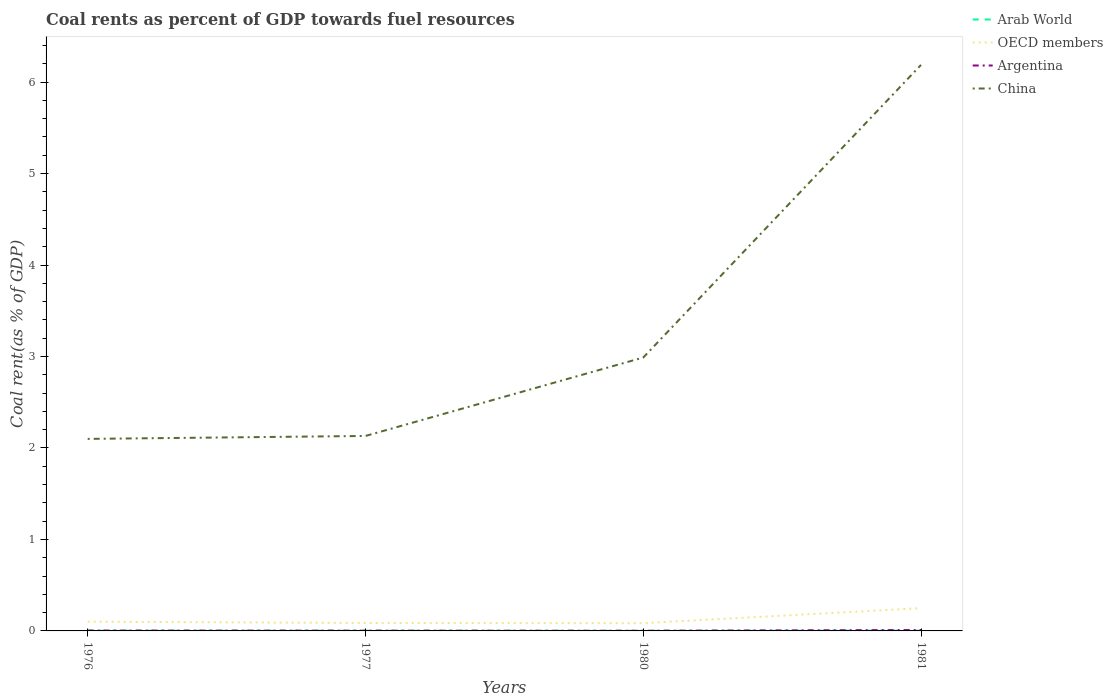Does the line corresponding to OECD members intersect with the line corresponding to China?
Ensure brevity in your answer.  No. Is the number of lines equal to the number of legend labels?
Provide a succinct answer. Yes. Across all years, what is the maximum coal rent in OECD members?
Your answer should be compact. 0.08. What is the total coal rent in OECD members in the graph?
Your answer should be very brief. -0.15. What is the difference between the highest and the second highest coal rent in Arab World?
Provide a succinct answer. 0. What is the difference between the highest and the lowest coal rent in China?
Ensure brevity in your answer.  1. Is the coal rent in Argentina strictly greater than the coal rent in Arab World over the years?
Make the answer very short. No. How many years are there in the graph?
Your answer should be very brief. 4. Does the graph contain any zero values?
Ensure brevity in your answer.  No. Does the graph contain grids?
Ensure brevity in your answer.  No. Where does the legend appear in the graph?
Ensure brevity in your answer.  Top right. How many legend labels are there?
Offer a very short reply. 4. What is the title of the graph?
Provide a short and direct response. Coal rents as percent of GDP towards fuel resources. What is the label or title of the X-axis?
Your answer should be very brief. Years. What is the label or title of the Y-axis?
Provide a succinct answer. Coal rent(as % of GDP). What is the Coal rent(as % of GDP) of Arab World in 1976?
Provide a short and direct response. 0. What is the Coal rent(as % of GDP) in OECD members in 1976?
Ensure brevity in your answer.  0.1. What is the Coal rent(as % of GDP) in Argentina in 1976?
Provide a short and direct response. 0. What is the Coal rent(as % of GDP) of China in 1976?
Ensure brevity in your answer.  2.1. What is the Coal rent(as % of GDP) of Arab World in 1977?
Ensure brevity in your answer.  0. What is the Coal rent(as % of GDP) in OECD members in 1977?
Offer a very short reply. 0.09. What is the Coal rent(as % of GDP) in Argentina in 1977?
Your answer should be very brief. 0. What is the Coal rent(as % of GDP) in China in 1977?
Ensure brevity in your answer.  2.13. What is the Coal rent(as % of GDP) of Arab World in 1980?
Provide a succinct answer. 0. What is the Coal rent(as % of GDP) of OECD members in 1980?
Provide a succinct answer. 0.08. What is the Coal rent(as % of GDP) of Argentina in 1980?
Offer a terse response. 0. What is the Coal rent(as % of GDP) in China in 1980?
Make the answer very short. 2.99. What is the Coal rent(as % of GDP) of Arab World in 1981?
Offer a terse response. 0. What is the Coal rent(as % of GDP) in OECD members in 1981?
Ensure brevity in your answer.  0.25. What is the Coal rent(as % of GDP) of Argentina in 1981?
Provide a short and direct response. 0.01. What is the Coal rent(as % of GDP) of China in 1981?
Offer a terse response. 6.19. Across all years, what is the maximum Coal rent(as % of GDP) in Arab World?
Offer a terse response. 0. Across all years, what is the maximum Coal rent(as % of GDP) in OECD members?
Your answer should be compact. 0.25. Across all years, what is the maximum Coal rent(as % of GDP) in Argentina?
Provide a short and direct response. 0.01. Across all years, what is the maximum Coal rent(as % of GDP) in China?
Give a very brief answer. 6.19. Across all years, what is the minimum Coal rent(as % of GDP) in Arab World?
Your answer should be compact. 0. Across all years, what is the minimum Coal rent(as % of GDP) in OECD members?
Ensure brevity in your answer.  0.08. Across all years, what is the minimum Coal rent(as % of GDP) in Argentina?
Ensure brevity in your answer.  0. Across all years, what is the minimum Coal rent(as % of GDP) of China?
Offer a very short reply. 2.1. What is the total Coal rent(as % of GDP) of Arab World in the graph?
Provide a short and direct response. 0.01. What is the total Coal rent(as % of GDP) of OECD members in the graph?
Give a very brief answer. 0.52. What is the total Coal rent(as % of GDP) in Argentina in the graph?
Offer a terse response. 0.02. What is the total Coal rent(as % of GDP) in China in the graph?
Make the answer very short. 13.41. What is the difference between the Coal rent(as % of GDP) in OECD members in 1976 and that in 1977?
Make the answer very short. 0.01. What is the difference between the Coal rent(as % of GDP) in Argentina in 1976 and that in 1977?
Provide a succinct answer. 0. What is the difference between the Coal rent(as % of GDP) of China in 1976 and that in 1977?
Offer a very short reply. -0.03. What is the difference between the Coal rent(as % of GDP) in Arab World in 1976 and that in 1980?
Offer a very short reply. 0. What is the difference between the Coal rent(as % of GDP) in OECD members in 1976 and that in 1980?
Give a very brief answer. 0.02. What is the difference between the Coal rent(as % of GDP) in Argentina in 1976 and that in 1980?
Provide a short and direct response. 0. What is the difference between the Coal rent(as % of GDP) in China in 1976 and that in 1980?
Ensure brevity in your answer.  -0.89. What is the difference between the Coal rent(as % of GDP) in Arab World in 1976 and that in 1981?
Provide a succinct answer. -0. What is the difference between the Coal rent(as % of GDP) in OECD members in 1976 and that in 1981?
Provide a short and direct response. -0.15. What is the difference between the Coal rent(as % of GDP) of Argentina in 1976 and that in 1981?
Your answer should be very brief. -0.01. What is the difference between the Coal rent(as % of GDP) in China in 1976 and that in 1981?
Your answer should be very brief. -4.09. What is the difference between the Coal rent(as % of GDP) in Arab World in 1977 and that in 1980?
Offer a terse response. 0. What is the difference between the Coal rent(as % of GDP) of OECD members in 1977 and that in 1980?
Offer a very short reply. 0. What is the difference between the Coal rent(as % of GDP) in China in 1977 and that in 1980?
Offer a very short reply. -0.86. What is the difference between the Coal rent(as % of GDP) of Arab World in 1977 and that in 1981?
Provide a short and direct response. -0. What is the difference between the Coal rent(as % of GDP) in OECD members in 1977 and that in 1981?
Offer a terse response. -0.16. What is the difference between the Coal rent(as % of GDP) in Argentina in 1977 and that in 1981?
Give a very brief answer. -0.01. What is the difference between the Coal rent(as % of GDP) of China in 1977 and that in 1981?
Keep it short and to the point. -4.06. What is the difference between the Coal rent(as % of GDP) of Arab World in 1980 and that in 1981?
Provide a short and direct response. -0. What is the difference between the Coal rent(as % of GDP) in OECD members in 1980 and that in 1981?
Give a very brief answer. -0.16. What is the difference between the Coal rent(as % of GDP) of Argentina in 1980 and that in 1981?
Provide a short and direct response. -0.01. What is the difference between the Coal rent(as % of GDP) in China in 1980 and that in 1981?
Give a very brief answer. -3.2. What is the difference between the Coal rent(as % of GDP) in Arab World in 1976 and the Coal rent(as % of GDP) in OECD members in 1977?
Make the answer very short. -0.08. What is the difference between the Coal rent(as % of GDP) in Arab World in 1976 and the Coal rent(as % of GDP) in Argentina in 1977?
Offer a terse response. 0. What is the difference between the Coal rent(as % of GDP) of Arab World in 1976 and the Coal rent(as % of GDP) of China in 1977?
Make the answer very short. -2.13. What is the difference between the Coal rent(as % of GDP) in OECD members in 1976 and the Coal rent(as % of GDP) in Argentina in 1977?
Provide a short and direct response. 0.1. What is the difference between the Coal rent(as % of GDP) in OECD members in 1976 and the Coal rent(as % of GDP) in China in 1977?
Your response must be concise. -2.03. What is the difference between the Coal rent(as % of GDP) in Argentina in 1976 and the Coal rent(as % of GDP) in China in 1977?
Your answer should be very brief. -2.13. What is the difference between the Coal rent(as % of GDP) of Arab World in 1976 and the Coal rent(as % of GDP) of OECD members in 1980?
Give a very brief answer. -0.08. What is the difference between the Coal rent(as % of GDP) in Arab World in 1976 and the Coal rent(as % of GDP) in Argentina in 1980?
Keep it short and to the point. 0. What is the difference between the Coal rent(as % of GDP) of Arab World in 1976 and the Coal rent(as % of GDP) of China in 1980?
Offer a very short reply. -2.99. What is the difference between the Coal rent(as % of GDP) in OECD members in 1976 and the Coal rent(as % of GDP) in Argentina in 1980?
Keep it short and to the point. 0.1. What is the difference between the Coal rent(as % of GDP) in OECD members in 1976 and the Coal rent(as % of GDP) in China in 1980?
Provide a succinct answer. -2.89. What is the difference between the Coal rent(as % of GDP) of Argentina in 1976 and the Coal rent(as % of GDP) of China in 1980?
Offer a terse response. -2.98. What is the difference between the Coal rent(as % of GDP) in Arab World in 1976 and the Coal rent(as % of GDP) in OECD members in 1981?
Ensure brevity in your answer.  -0.25. What is the difference between the Coal rent(as % of GDP) of Arab World in 1976 and the Coal rent(as % of GDP) of Argentina in 1981?
Offer a very short reply. -0.01. What is the difference between the Coal rent(as % of GDP) of Arab World in 1976 and the Coal rent(as % of GDP) of China in 1981?
Ensure brevity in your answer.  -6.18. What is the difference between the Coal rent(as % of GDP) of OECD members in 1976 and the Coal rent(as % of GDP) of Argentina in 1981?
Your response must be concise. 0.09. What is the difference between the Coal rent(as % of GDP) of OECD members in 1976 and the Coal rent(as % of GDP) of China in 1981?
Offer a very short reply. -6.09. What is the difference between the Coal rent(as % of GDP) in Argentina in 1976 and the Coal rent(as % of GDP) in China in 1981?
Provide a short and direct response. -6.18. What is the difference between the Coal rent(as % of GDP) in Arab World in 1977 and the Coal rent(as % of GDP) in OECD members in 1980?
Offer a very short reply. -0.08. What is the difference between the Coal rent(as % of GDP) of Arab World in 1977 and the Coal rent(as % of GDP) of Argentina in 1980?
Your response must be concise. 0. What is the difference between the Coal rent(as % of GDP) in Arab World in 1977 and the Coal rent(as % of GDP) in China in 1980?
Your answer should be compact. -2.99. What is the difference between the Coal rent(as % of GDP) of OECD members in 1977 and the Coal rent(as % of GDP) of Argentina in 1980?
Give a very brief answer. 0.09. What is the difference between the Coal rent(as % of GDP) of OECD members in 1977 and the Coal rent(as % of GDP) of China in 1980?
Provide a short and direct response. -2.9. What is the difference between the Coal rent(as % of GDP) in Argentina in 1977 and the Coal rent(as % of GDP) in China in 1980?
Provide a succinct answer. -2.99. What is the difference between the Coal rent(as % of GDP) in Arab World in 1977 and the Coal rent(as % of GDP) in OECD members in 1981?
Keep it short and to the point. -0.25. What is the difference between the Coal rent(as % of GDP) of Arab World in 1977 and the Coal rent(as % of GDP) of Argentina in 1981?
Offer a very short reply. -0.01. What is the difference between the Coal rent(as % of GDP) of Arab World in 1977 and the Coal rent(as % of GDP) of China in 1981?
Your answer should be very brief. -6.19. What is the difference between the Coal rent(as % of GDP) of OECD members in 1977 and the Coal rent(as % of GDP) of Argentina in 1981?
Your answer should be very brief. 0.08. What is the difference between the Coal rent(as % of GDP) of OECD members in 1977 and the Coal rent(as % of GDP) of China in 1981?
Offer a terse response. -6.1. What is the difference between the Coal rent(as % of GDP) of Argentina in 1977 and the Coal rent(as % of GDP) of China in 1981?
Offer a terse response. -6.19. What is the difference between the Coal rent(as % of GDP) in Arab World in 1980 and the Coal rent(as % of GDP) in OECD members in 1981?
Keep it short and to the point. -0.25. What is the difference between the Coal rent(as % of GDP) in Arab World in 1980 and the Coal rent(as % of GDP) in Argentina in 1981?
Give a very brief answer. -0.01. What is the difference between the Coal rent(as % of GDP) of Arab World in 1980 and the Coal rent(as % of GDP) of China in 1981?
Ensure brevity in your answer.  -6.19. What is the difference between the Coal rent(as % of GDP) in OECD members in 1980 and the Coal rent(as % of GDP) in Argentina in 1981?
Ensure brevity in your answer.  0.07. What is the difference between the Coal rent(as % of GDP) of OECD members in 1980 and the Coal rent(as % of GDP) of China in 1981?
Offer a very short reply. -6.1. What is the difference between the Coal rent(as % of GDP) in Argentina in 1980 and the Coal rent(as % of GDP) in China in 1981?
Offer a very short reply. -6.19. What is the average Coal rent(as % of GDP) of Arab World per year?
Your answer should be compact. 0. What is the average Coal rent(as % of GDP) of OECD members per year?
Keep it short and to the point. 0.13. What is the average Coal rent(as % of GDP) in Argentina per year?
Keep it short and to the point. 0. What is the average Coal rent(as % of GDP) in China per year?
Your answer should be compact. 3.35. In the year 1976, what is the difference between the Coal rent(as % of GDP) in Arab World and Coal rent(as % of GDP) in OECD members?
Keep it short and to the point. -0.1. In the year 1976, what is the difference between the Coal rent(as % of GDP) of Arab World and Coal rent(as % of GDP) of Argentina?
Offer a terse response. -0. In the year 1976, what is the difference between the Coal rent(as % of GDP) in Arab World and Coal rent(as % of GDP) in China?
Your answer should be compact. -2.1. In the year 1976, what is the difference between the Coal rent(as % of GDP) in OECD members and Coal rent(as % of GDP) in Argentina?
Your answer should be compact. 0.1. In the year 1976, what is the difference between the Coal rent(as % of GDP) of OECD members and Coal rent(as % of GDP) of China?
Keep it short and to the point. -2. In the year 1976, what is the difference between the Coal rent(as % of GDP) in Argentina and Coal rent(as % of GDP) in China?
Provide a succinct answer. -2.1. In the year 1977, what is the difference between the Coal rent(as % of GDP) of Arab World and Coal rent(as % of GDP) of OECD members?
Offer a very short reply. -0.08. In the year 1977, what is the difference between the Coal rent(as % of GDP) in Arab World and Coal rent(as % of GDP) in Argentina?
Provide a short and direct response. -0. In the year 1977, what is the difference between the Coal rent(as % of GDP) of Arab World and Coal rent(as % of GDP) of China?
Offer a very short reply. -2.13. In the year 1977, what is the difference between the Coal rent(as % of GDP) of OECD members and Coal rent(as % of GDP) of Argentina?
Offer a very short reply. 0.08. In the year 1977, what is the difference between the Coal rent(as % of GDP) in OECD members and Coal rent(as % of GDP) in China?
Your response must be concise. -2.04. In the year 1977, what is the difference between the Coal rent(as % of GDP) of Argentina and Coal rent(as % of GDP) of China?
Make the answer very short. -2.13. In the year 1980, what is the difference between the Coal rent(as % of GDP) in Arab World and Coal rent(as % of GDP) in OECD members?
Ensure brevity in your answer.  -0.08. In the year 1980, what is the difference between the Coal rent(as % of GDP) in Arab World and Coal rent(as % of GDP) in Argentina?
Offer a terse response. -0. In the year 1980, what is the difference between the Coal rent(as % of GDP) of Arab World and Coal rent(as % of GDP) of China?
Offer a very short reply. -2.99. In the year 1980, what is the difference between the Coal rent(as % of GDP) of OECD members and Coal rent(as % of GDP) of Argentina?
Offer a very short reply. 0.08. In the year 1980, what is the difference between the Coal rent(as % of GDP) of OECD members and Coal rent(as % of GDP) of China?
Provide a short and direct response. -2.9. In the year 1980, what is the difference between the Coal rent(as % of GDP) in Argentina and Coal rent(as % of GDP) in China?
Keep it short and to the point. -2.99. In the year 1981, what is the difference between the Coal rent(as % of GDP) in Arab World and Coal rent(as % of GDP) in OECD members?
Make the answer very short. -0.25. In the year 1981, what is the difference between the Coal rent(as % of GDP) in Arab World and Coal rent(as % of GDP) in Argentina?
Provide a succinct answer. -0.01. In the year 1981, what is the difference between the Coal rent(as % of GDP) in Arab World and Coal rent(as % of GDP) in China?
Offer a terse response. -6.18. In the year 1981, what is the difference between the Coal rent(as % of GDP) in OECD members and Coal rent(as % of GDP) in Argentina?
Your answer should be compact. 0.24. In the year 1981, what is the difference between the Coal rent(as % of GDP) in OECD members and Coal rent(as % of GDP) in China?
Offer a terse response. -5.94. In the year 1981, what is the difference between the Coal rent(as % of GDP) of Argentina and Coal rent(as % of GDP) of China?
Offer a very short reply. -6.18. What is the ratio of the Coal rent(as % of GDP) in Arab World in 1976 to that in 1977?
Your response must be concise. 1.16. What is the ratio of the Coal rent(as % of GDP) of OECD members in 1976 to that in 1977?
Ensure brevity in your answer.  1.16. What is the ratio of the Coal rent(as % of GDP) of Argentina in 1976 to that in 1977?
Ensure brevity in your answer.  1.43. What is the ratio of the Coal rent(as % of GDP) in China in 1976 to that in 1977?
Offer a terse response. 0.98. What is the ratio of the Coal rent(as % of GDP) of Arab World in 1976 to that in 1980?
Your response must be concise. 1.87. What is the ratio of the Coal rent(as % of GDP) in OECD members in 1976 to that in 1980?
Ensure brevity in your answer.  1.19. What is the ratio of the Coal rent(as % of GDP) in Argentina in 1976 to that in 1980?
Make the answer very short. 2.22. What is the ratio of the Coal rent(as % of GDP) of China in 1976 to that in 1980?
Your answer should be compact. 0.7. What is the ratio of the Coal rent(as % of GDP) of Arab World in 1976 to that in 1981?
Your answer should be compact. 0.88. What is the ratio of the Coal rent(as % of GDP) of OECD members in 1976 to that in 1981?
Offer a very short reply. 0.41. What is the ratio of the Coal rent(as % of GDP) of Argentina in 1976 to that in 1981?
Offer a very short reply. 0.4. What is the ratio of the Coal rent(as % of GDP) in China in 1976 to that in 1981?
Provide a short and direct response. 0.34. What is the ratio of the Coal rent(as % of GDP) of Arab World in 1977 to that in 1980?
Provide a succinct answer. 1.62. What is the ratio of the Coal rent(as % of GDP) in OECD members in 1977 to that in 1980?
Your response must be concise. 1.03. What is the ratio of the Coal rent(as % of GDP) in Argentina in 1977 to that in 1980?
Keep it short and to the point. 1.55. What is the ratio of the Coal rent(as % of GDP) of China in 1977 to that in 1980?
Offer a terse response. 0.71. What is the ratio of the Coal rent(as % of GDP) of Arab World in 1977 to that in 1981?
Make the answer very short. 0.76. What is the ratio of the Coal rent(as % of GDP) in OECD members in 1977 to that in 1981?
Give a very brief answer. 0.35. What is the ratio of the Coal rent(as % of GDP) in Argentina in 1977 to that in 1981?
Provide a short and direct response. 0.28. What is the ratio of the Coal rent(as % of GDP) of China in 1977 to that in 1981?
Provide a short and direct response. 0.34. What is the ratio of the Coal rent(as % of GDP) in Arab World in 1980 to that in 1981?
Your answer should be compact. 0.47. What is the ratio of the Coal rent(as % of GDP) of OECD members in 1980 to that in 1981?
Keep it short and to the point. 0.34. What is the ratio of the Coal rent(as % of GDP) of Argentina in 1980 to that in 1981?
Your answer should be very brief. 0.18. What is the ratio of the Coal rent(as % of GDP) of China in 1980 to that in 1981?
Keep it short and to the point. 0.48. What is the difference between the highest and the second highest Coal rent(as % of GDP) of Arab World?
Your answer should be compact. 0. What is the difference between the highest and the second highest Coal rent(as % of GDP) of OECD members?
Ensure brevity in your answer.  0.15. What is the difference between the highest and the second highest Coal rent(as % of GDP) in Argentina?
Offer a terse response. 0.01. What is the difference between the highest and the second highest Coal rent(as % of GDP) in China?
Your answer should be compact. 3.2. What is the difference between the highest and the lowest Coal rent(as % of GDP) in Arab World?
Your answer should be compact. 0. What is the difference between the highest and the lowest Coal rent(as % of GDP) in OECD members?
Give a very brief answer. 0.16. What is the difference between the highest and the lowest Coal rent(as % of GDP) in Argentina?
Your response must be concise. 0.01. What is the difference between the highest and the lowest Coal rent(as % of GDP) in China?
Your answer should be compact. 4.09. 